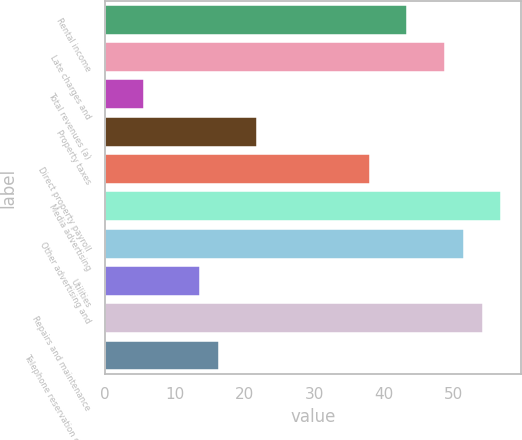<chart> <loc_0><loc_0><loc_500><loc_500><bar_chart><fcel>Rental income<fcel>Late charges and<fcel>Total revenues (a)<fcel>Property taxes<fcel>Direct property payroll<fcel>Media advertising<fcel>Other advertising and<fcel>Utilities<fcel>Repairs and maintenance<fcel>Telephone reservation center<nl><fcel>43.3<fcel>48.7<fcel>5.5<fcel>21.7<fcel>37.9<fcel>56.8<fcel>51.4<fcel>13.6<fcel>54.1<fcel>16.3<nl></chart> 